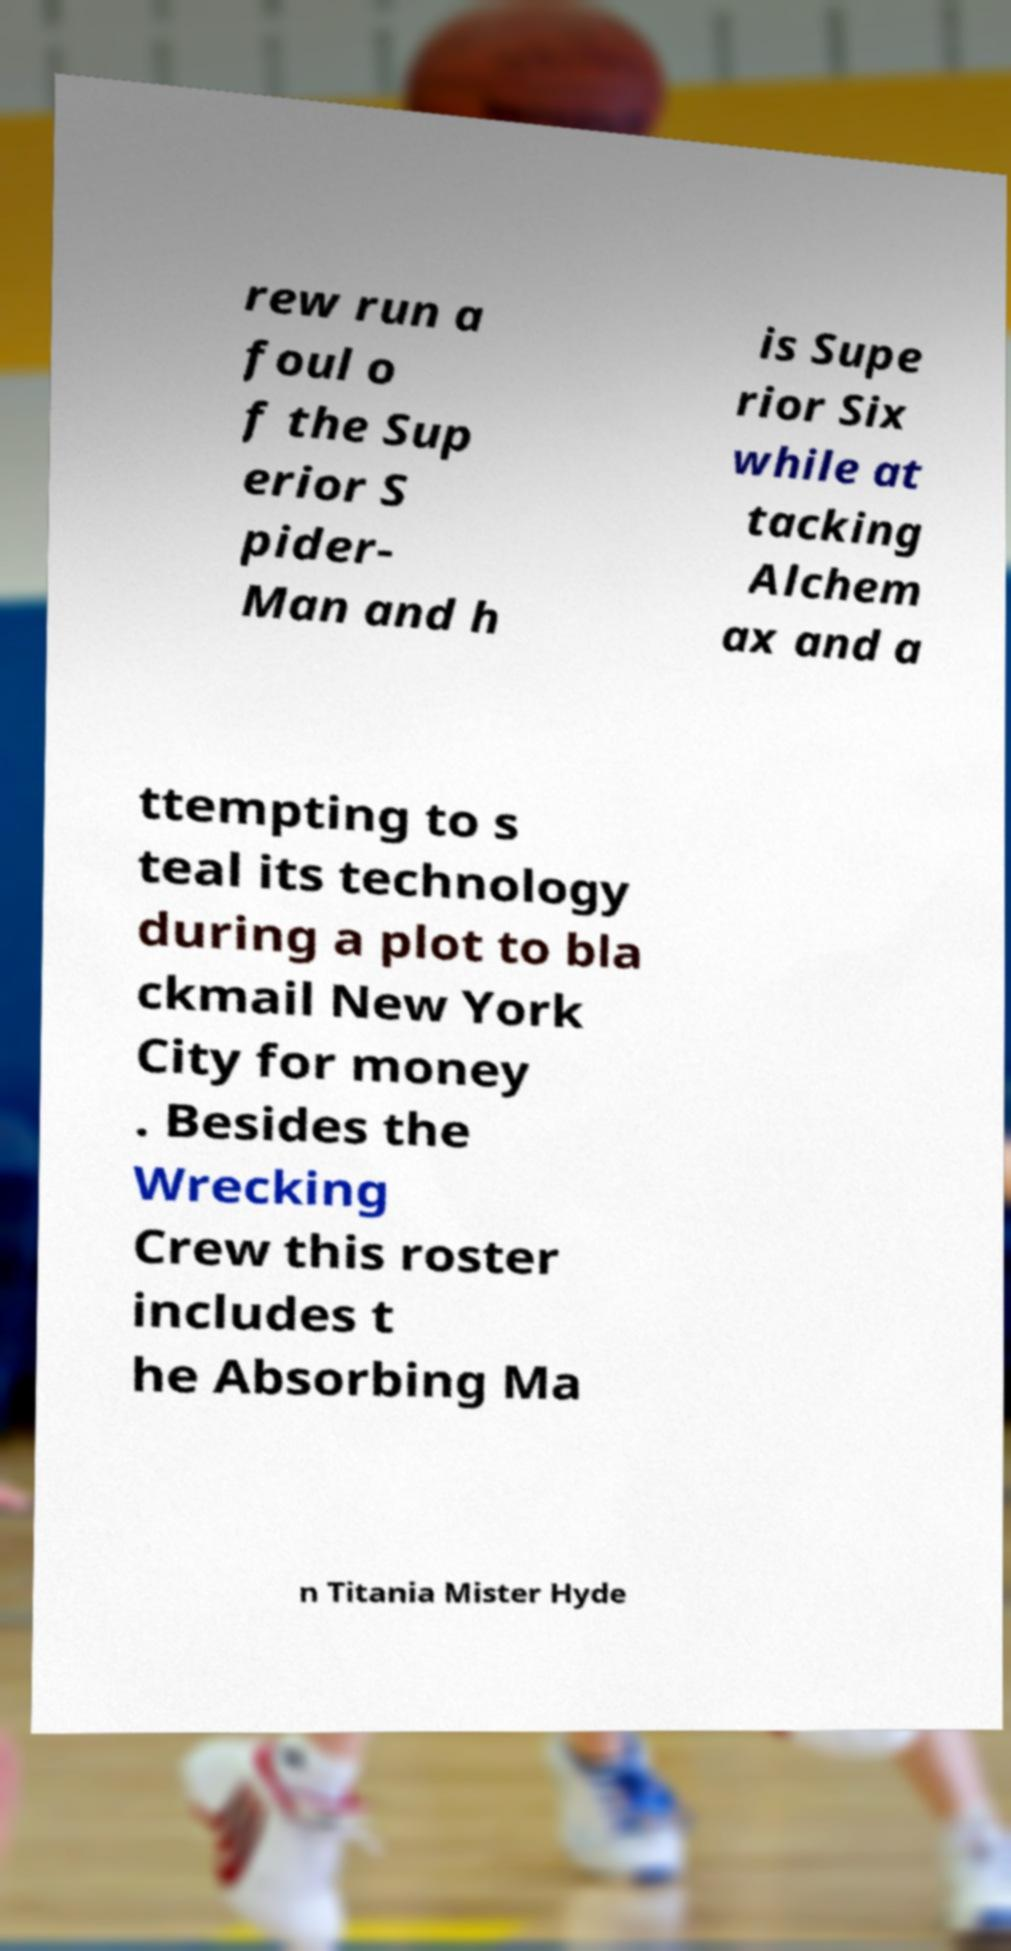Please read and relay the text visible in this image. What does it say? rew run a foul o f the Sup erior S pider- Man and h is Supe rior Six while at tacking Alchem ax and a ttempting to s teal its technology during a plot to bla ckmail New York City for money . Besides the Wrecking Crew this roster includes t he Absorbing Ma n Titania Mister Hyde 